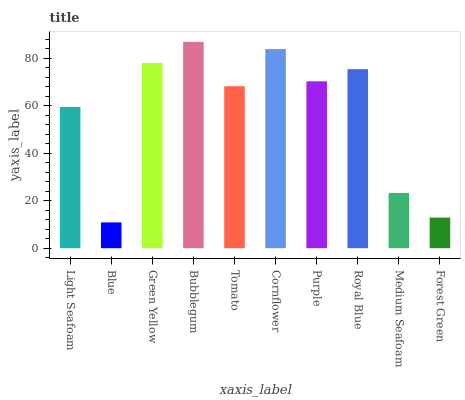Is Blue the minimum?
Answer yes or no. Yes. Is Bubblegum the maximum?
Answer yes or no. Yes. Is Green Yellow the minimum?
Answer yes or no. No. Is Green Yellow the maximum?
Answer yes or no. No. Is Green Yellow greater than Blue?
Answer yes or no. Yes. Is Blue less than Green Yellow?
Answer yes or no. Yes. Is Blue greater than Green Yellow?
Answer yes or no. No. Is Green Yellow less than Blue?
Answer yes or no. No. Is Purple the high median?
Answer yes or no. Yes. Is Tomato the low median?
Answer yes or no. Yes. Is Green Yellow the high median?
Answer yes or no. No. Is Medium Seafoam the low median?
Answer yes or no. No. 